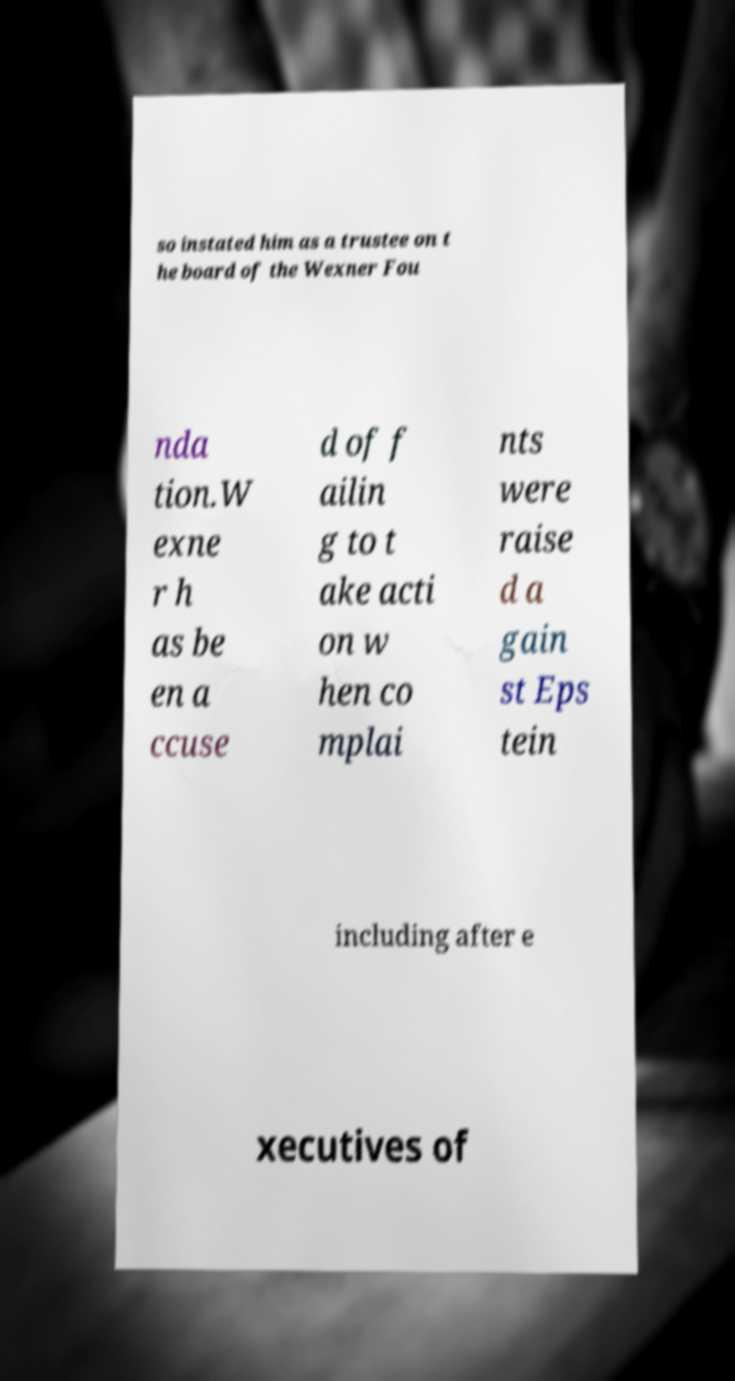Please identify and transcribe the text found in this image. so instated him as a trustee on t he board of the Wexner Fou nda tion.W exne r h as be en a ccuse d of f ailin g to t ake acti on w hen co mplai nts were raise d a gain st Eps tein including after e xecutives of 